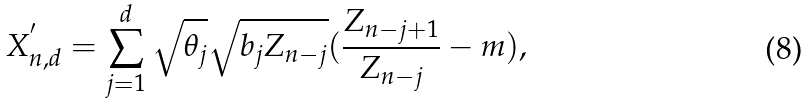Convert formula to latex. <formula><loc_0><loc_0><loc_500><loc_500>X _ { n , d } ^ { ^ { \prime } } = \sum _ { j = 1 } ^ { d } \sqrt { \theta _ { j } } \sqrt { b _ { j } Z _ { n - j } } ( \frac { Z _ { n - j + 1 } } { Z _ { n - j } } - m ) ,</formula> 